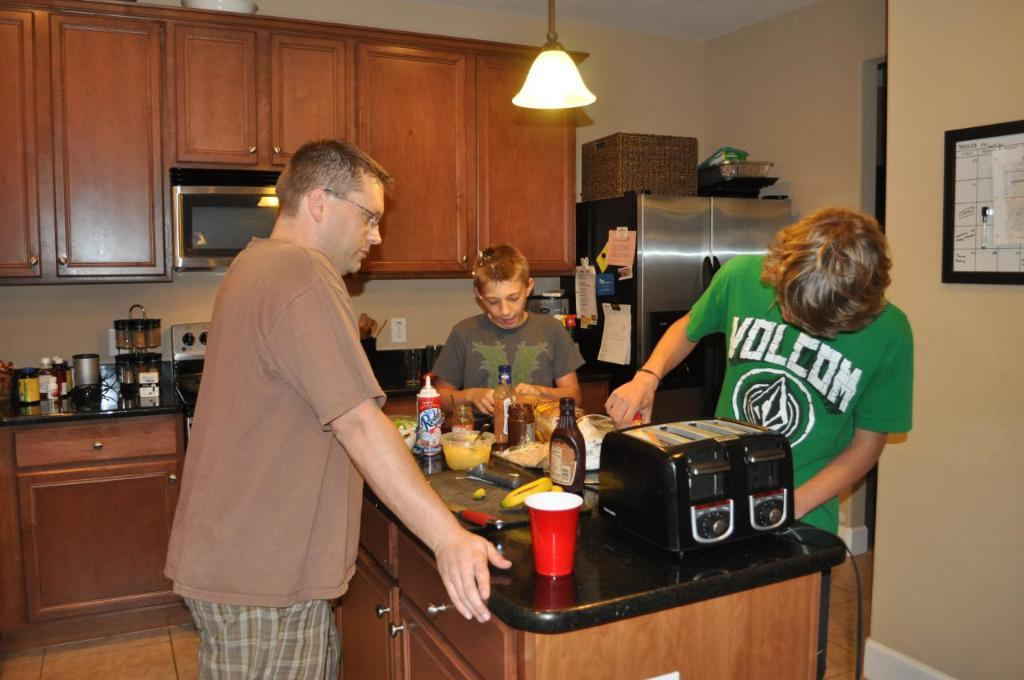<image>
Give a short and clear explanation of the subsequent image. three males are making food in a kitchen, with one wearing a Volcom shirt 